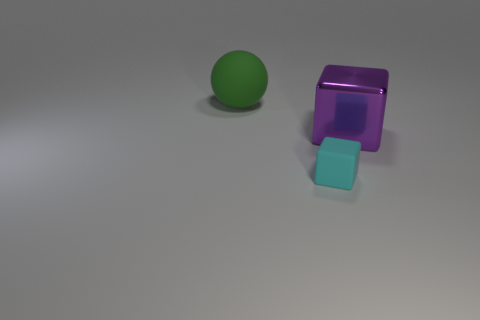Add 2 gray matte balls. How many objects exist? 5 Subtract all balls. How many objects are left? 2 Subtract all purple metal objects. Subtract all cyan rubber blocks. How many objects are left? 1 Add 3 cubes. How many cubes are left? 5 Add 3 green rubber spheres. How many green rubber spheres exist? 4 Subtract 0 gray cylinders. How many objects are left? 3 